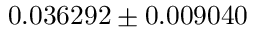Convert formula to latex. <formula><loc_0><loc_0><loc_500><loc_500>0 . 0 3 6 2 9 2 \pm 0 . 0 0 9 0 4 0</formula> 